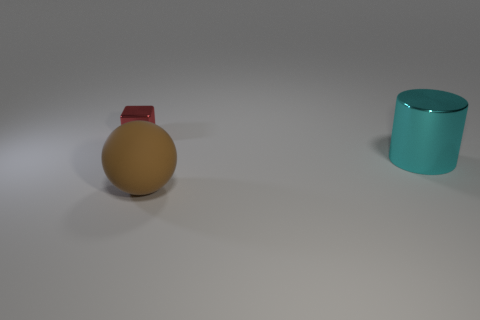How many large cyan cylinders have the same material as the small block?
Ensure brevity in your answer.  1. There is a cylinder that is made of the same material as the tiny block; what is its color?
Offer a very short reply. Cyan. There is a block; does it have the same size as the brown rubber thing in front of the metal cylinder?
Provide a short and direct response. No. There is a large thing that is to the right of the thing that is in front of the metal thing that is to the right of the big sphere; what is its material?
Your answer should be compact. Metal. How many objects are either cyan objects or tiny blue rubber things?
Your answer should be very brief. 1. There is a big thing that is in front of the large cyan thing; is its color the same as the metal object in front of the tiny metal object?
Keep it short and to the point. No. What is the shape of the thing that is the same size as the cylinder?
Provide a succinct answer. Sphere. How many objects are large things behind the brown matte sphere or objects that are on the right side of the large brown rubber sphere?
Offer a terse response. 1. Is the number of blocks less than the number of brown matte cubes?
Give a very brief answer. No. There is a thing that is the same size as the cyan metallic cylinder; what material is it?
Provide a succinct answer. Rubber. 